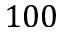Convert formula to latex. <formula><loc_0><loc_0><loc_500><loc_500>1 0 0</formula> 